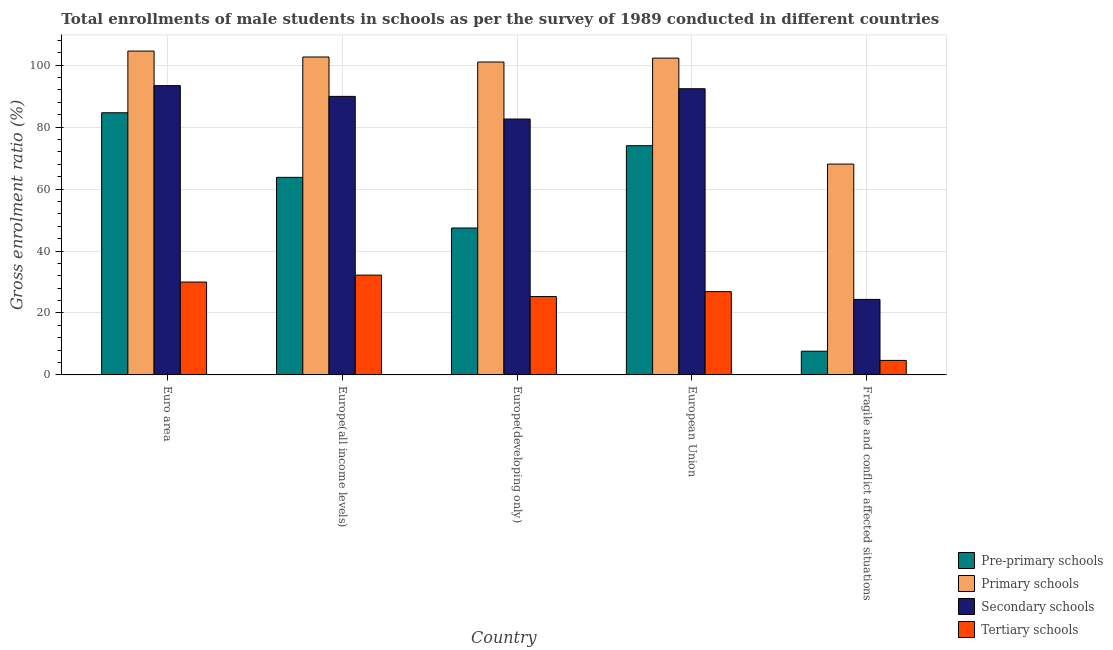How many bars are there on the 2nd tick from the left?
Offer a very short reply. 4. How many bars are there on the 4th tick from the right?
Your answer should be very brief. 4. What is the label of the 5th group of bars from the left?
Offer a very short reply. Fragile and conflict affected situations. In how many cases, is the number of bars for a given country not equal to the number of legend labels?
Keep it short and to the point. 0. What is the gross enrolment ratio(male) in secondary schools in Euro area?
Offer a terse response. 93.39. Across all countries, what is the maximum gross enrolment ratio(male) in pre-primary schools?
Keep it short and to the point. 84.63. Across all countries, what is the minimum gross enrolment ratio(male) in primary schools?
Offer a terse response. 68.07. In which country was the gross enrolment ratio(male) in tertiary schools maximum?
Provide a short and direct response. Europe(all income levels). In which country was the gross enrolment ratio(male) in primary schools minimum?
Offer a terse response. Fragile and conflict affected situations. What is the total gross enrolment ratio(male) in secondary schools in the graph?
Your answer should be very brief. 382.68. What is the difference between the gross enrolment ratio(male) in secondary schools in Europe(all income levels) and that in European Union?
Provide a succinct answer. -2.47. What is the difference between the gross enrolment ratio(male) in primary schools in Euro area and the gross enrolment ratio(male) in tertiary schools in Europe(all income levels)?
Provide a succinct answer. 72.33. What is the average gross enrolment ratio(male) in tertiary schools per country?
Ensure brevity in your answer.  23.81. What is the difference between the gross enrolment ratio(male) in primary schools and gross enrolment ratio(male) in secondary schools in Europe(all income levels)?
Keep it short and to the point. 12.72. What is the ratio of the gross enrolment ratio(male) in secondary schools in Euro area to that in European Union?
Provide a short and direct response. 1.01. What is the difference between the highest and the second highest gross enrolment ratio(male) in tertiary schools?
Ensure brevity in your answer.  2.24. What is the difference between the highest and the lowest gross enrolment ratio(male) in primary schools?
Provide a succinct answer. 36.48. In how many countries, is the gross enrolment ratio(male) in secondary schools greater than the average gross enrolment ratio(male) in secondary schools taken over all countries?
Keep it short and to the point. 4. Is the sum of the gross enrolment ratio(male) in primary schools in Euro area and Fragile and conflict affected situations greater than the maximum gross enrolment ratio(male) in pre-primary schools across all countries?
Provide a succinct answer. Yes. What does the 1st bar from the left in Fragile and conflict affected situations represents?
Ensure brevity in your answer.  Pre-primary schools. What does the 4th bar from the right in European Union represents?
Make the answer very short. Pre-primary schools. Is it the case that in every country, the sum of the gross enrolment ratio(male) in pre-primary schools and gross enrolment ratio(male) in primary schools is greater than the gross enrolment ratio(male) in secondary schools?
Provide a succinct answer. Yes. How many bars are there?
Make the answer very short. 20. How many countries are there in the graph?
Your response must be concise. 5. What is the difference between two consecutive major ticks on the Y-axis?
Offer a terse response. 20. Are the values on the major ticks of Y-axis written in scientific E-notation?
Provide a succinct answer. No. Does the graph contain grids?
Keep it short and to the point. Yes. Where does the legend appear in the graph?
Your answer should be compact. Bottom right. What is the title of the graph?
Make the answer very short. Total enrollments of male students in schools as per the survey of 1989 conducted in different countries. What is the label or title of the X-axis?
Keep it short and to the point. Country. What is the Gross enrolment ratio (%) of Pre-primary schools in Euro area?
Make the answer very short. 84.63. What is the Gross enrolment ratio (%) in Primary schools in Euro area?
Offer a very short reply. 104.55. What is the Gross enrolment ratio (%) in Secondary schools in Euro area?
Your answer should be compact. 93.39. What is the Gross enrolment ratio (%) of Tertiary schools in Euro area?
Offer a terse response. 29.98. What is the Gross enrolment ratio (%) in Pre-primary schools in Europe(all income levels)?
Your answer should be compact. 63.78. What is the Gross enrolment ratio (%) in Primary schools in Europe(all income levels)?
Your response must be concise. 102.63. What is the Gross enrolment ratio (%) of Secondary schools in Europe(all income levels)?
Provide a succinct answer. 89.92. What is the Gross enrolment ratio (%) in Tertiary schools in Europe(all income levels)?
Your response must be concise. 32.22. What is the Gross enrolment ratio (%) of Pre-primary schools in Europe(developing only)?
Provide a short and direct response. 47.42. What is the Gross enrolment ratio (%) in Primary schools in Europe(developing only)?
Your answer should be compact. 101.01. What is the Gross enrolment ratio (%) of Secondary schools in Europe(developing only)?
Make the answer very short. 82.61. What is the Gross enrolment ratio (%) of Tertiary schools in Europe(developing only)?
Make the answer very short. 25.29. What is the Gross enrolment ratio (%) of Pre-primary schools in European Union?
Your response must be concise. 73.99. What is the Gross enrolment ratio (%) in Primary schools in European Union?
Give a very brief answer. 102.27. What is the Gross enrolment ratio (%) in Secondary schools in European Union?
Ensure brevity in your answer.  92.39. What is the Gross enrolment ratio (%) in Tertiary schools in European Union?
Your response must be concise. 26.89. What is the Gross enrolment ratio (%) of Pre-primary schools in Fragile and conflict affected situations?
Your answer should be compact. 7.65. What is the Gross enrolment ratio (%) in Primary schools in Fragile and conflict affected situations?
Give a very brief answer. 68.07. What is the Gross enrolment ratio (%) in Secondary schools in Fragile and conflict affected situations?
Offer a terse response. 24.38. What is the Gross enrolment ratio (%) of Tertiary schools in Fragile and conflict affected situations?
Offer a terse response. 4.68. Across all countries, what is the maximum Gross enrolment ratio (%) of Pre-primary schools?
Your answer should be compact. 84.63. Across all countries, what is the maximum Gross enrolment ratio (%) of Primary schools?
Make the answer very short. 104.55. Across all countries, what is the maximum Gross enrolment ratio (%) of Secondary schools?
Your answer should be compact. 93.39. Across all countries, what is the maximum Gross enrolment ratio (%) of Tertiary schools?
Provide a succinct answer. 32.22. Across all countries, what is the minimum Gross enrolment ratio (%) of Pre-primary schools?
Provide a short and direct response. 7.65. Across all countries, what is the minimum Gross enrolment ratio (%) in Primary schools?
Your response must be concise. 68.07. Across all countries, what is the minimum Gross enrolment ratio (%) of Secondary schools?
Offer a very short reply. 24.38. Across all countries, what is the minimum Gross enrolment ratio (%) in Tertiary schools?
Offer a terse response. 4.68. What is the total Gross enrolment ratio (%) in Pre-primary schools in the graph?
Your response must be concise. 277.47. What is the total Gross enrolment ratio (%) in Primary schools in the graph?
Ensure brevity in your answer.  478.53. What is the total Gross enrolment ratio (%) of Secondary schools in the graph?
Offer a terse response. 382.68. What is the total Gross enrolment ratio (%) in Tertiary schools in the graph?
Offer a very short reply. 119.06. What is the difference between the Gross enrolment ratio (%) of Pre-primary schools in Euro area and that in Europe(all income levels)?
Provide a succinct answer. 20.85. What is the difference between the Gross enrolment ratio (%) in Primary schools in Euro area and that in Europe(all income levels)?
Your answer should be compact. 1.91. What is the difference between the Gross enrolment ratio (%) in Secondary schools in Euro area and that in Europe(all income levels)?
Ensure brevity in your answer.  3.47. What is the difference between the Gross enrolment ratio (%) of Tertiary schools in Euro area and that in Europe(all income levels)?
Your response must be concise. -2.24. What is the difference between the Gross enrolment ratio (%) in Pre-primary schools in Euro area and that in Europe(developing only)?
Offer a terse response. 37.21. What is the difference between the Gross enrolment ratio (%) of Primary schools in Euro area and that in Europe(developing only)?
Your response must be concise. 3.54. What is the difference between the Gross enrolment ratio (%) of Secondary schools in Euro area and that in Europe(developing only)?
Provide a succinct answer. 10.79. What is the difference between the Gross enrolment ratio (%) in Tertiary schools in Euro area and that in Europe(developing only)?
Provide a succinct answer. 4.69. What is the difference between the Gross enrolment ratio (%) of Pre-primary schools in Euro area and that in European Union?
Provide a short and direct response. 10.64. What is the difference between the Gross enrolment ratio (%) in Primary schools in Euro area and that in European Union?
Provide a short and direct response. 2.28. What is the difference between the Gross enrolment ratio (%) in Tertiary schools in Euro area and that in European Union?
Provide a succinct answer. 3.09. What is the difference between the Gross enrolment ratio (%) in Pre-primary schools in Euro area and that in Fragile and conflict affected situations?
Your answer should be compact. 76.98. What is the difference between the Gross enrolment ratio (%) of Primary schools in Euro area and that in Fragile and conflict affected situations?
Your answer should be very brief. 36.48. What is the difference between the Gross enrolment ratio (%) in Secondary schools in Euro area and that in Fragile and conflict affected situations?
Your answer should be very brief. 69.01. What is the difference between the Gross enrolment ratio (%) in Tertiary schools in Euro area and that in Fragile and conflict affected situations?
Ensure brevity in your answer.  25.3. What is the difference between the Gross enrolment ratio (%) of Pre-primary schools in Europe(all income levels) and that in Europe(developing only)?
Make the answer very short. 16.35. What is the difference between the Gross enrolment ratio (%) in Primary schools in Europe(all income levels) and that in Europe(developing only)?
Make the answer very short. 1.62. What is the difference between the Gross enrolment ratio (%) of Secondary schools in Europe(all income levels) and that in Europe(developing only)?
Give a very brief answer. 7.31. What is the difference between the Gross enrolment ratio (%) of Tertiary schools in Europe(all income levels) and that in Europe(developing only)?
Make the answer very short. 6.93. What is the difference between the Gross enrolment ratio (%) in Pre-primary schools in Europe(all income levels) and that in European Union?
Give a very brief answer. -10.21. What is the difference between the Gross enrolment ratio (%) of Primary schools in Europe(all income levels) and that in European Union?
Provide a short and direct response. 0.36. What is the difference between the Gross enrolment ratio (%) of Secondary schools in Europe(all income levels) and that in European Union?
Ensure brevity in your answer.  -2.47. What is the difference between the Gross enrolment ratio (%) of Tertiary schools in Europe(all income levels) and that in European Union?
Your answer should be compact. 5.33. What is the difference between the Gross enrolment ratio (%) of Pre-primary schools in Europe(all income levels) and that in Fragile and conflict affected situations?
Make the answer very short. 56.13. What is the difference between the Gross enrolment ratio (%) in Primary schools in Europe(all income levels) and that in Fragile and conflict affected situations?
Make the answer very short. 34.57. What is the difference between the Gross enrolment ratio (%) of Secondary schools in Europe(all income levels) and that in Fragile and conflict affected situations?
Offer a terse response. 65.54. What is the difference between the Gross enrolment ratio (%) in Tertiary schools in Europe(all income levels) and that in Fragile and conflict affected situations?
Offer a terse response. 27.54. What is the difference between the Gross enrolment ratio (%) in Pre-primary schools in Europe(developing only) and that in European Union?
Your answer should be very brief. -26.57. What is the difference between the Gross enrolment ratio (%) in Primary schools in Europe(developing only) and that in European Union?
Ensure brevity in your answer.  -1.26. What is the difference between the Gross enrolment ratio (%) in Secondary schools in Europe(developing only) and that in European Union?
Make the answer very short. -9.78. What is the difference between the Gross enrolment ratio (%) of Tertiary schools in Europe(developing only) and that in European Union?
Your response must be concise. -1.6. What is the difference between the Gross enrolment ratio (%) in Pre-primary schools in Europe(developing only) and that in Fragile and conflict affected situations?
Offer a very short reply. 39.77. What is the difference between the Gross enrolment ratio (%) of Primary schools in Europe(developing only) and that in Fragile and conflict affected situations?
Keep it short and to the point. 32.94. What is the difference between the Gross enrolment ratio (%) of Secondary schools in Europe(developing only) and that in Fragile and conflict affected situations?
Make the answer very short. 58.23. What is the difference between the Gross enrolment ratio (%) of Tertiary schools in Europe(developing only) and that in Fragile and conflict affected situations?
Your answer should be very brief. 20.61. What is the difference between the Gross enrolment ratio (%) of Pre-primary schools in European Union and that in Fragile and conflict affected situations?
Provide a succinct answer. 66.34. What is the difference between the Gross enrolment ratio (%) in Primary schools in European Union and that in Fragile and conflict affected situations?
Your answer should be compact. 34.2. What is the difference between the Gross enrolment ratio (%) of Secondary schools in European Union and that in Fragile and conflict affected situations?
Your answer should be very brief. 68.01. What is the difference between the Gross enrolment ratio (%) in Tertiary schools in European Union and that in Fragile and conflict affected situations?
Ensure brevity in your answer.  22.21. What is the difference between the Gross enrolment ratio (%) of Pre-primary schools in Euro area and the Gross enrolment ratio (%) of Primary schools in Europe(all income levels)?
Offer a terse response. -18. What is the difference between the Gross enrolment ratio (%) in Pre-primary schools in Euro area and the Gross enrolment ratio (%) in Secondary schools in Europe(all income levels)?
Your response must be concise. -5.29. What is the difference between the Gross enrolment ratio (%) in Pre-primary schools in Euro area and the Gross enrolment ratio (%) in Tertiary schools in Europe(all income levels)?
Your answer should be compact. 52.41. What is the difference between the Gross enrolment ratio (%) of Primary schools in Euro area and the Gross enrolment ratio (%) of Secondary schools in Europe(all income levels)?
Give a very brief answer. 14.63. What is the difference between the Gross enrolment ratio (%) of Primary schools in Euro area and the Gross enrolment ratio (%) of Tertiary schools in Europe(all income levels)?
Your answer should be compact. 72.33. What is the difference between the Gross enrolment ratio (%) of Secondary schools in Euro area and the Gross enrolment ratio (%) of Tertiary schools in Europe(all income levels)?
Keep it short and to the point. 61.17. What is the difference between the Gross enrolment ratio (%) of Pre-primary schools in Euro area and the Gross enrolment ratio (%) of Primary schools in Europe(developing only)?
Provide a short and direct response. -16.38. What is the difference between the Gross enrolment ratio (%) of Pre-primary schools in Euro area and the Gross enrolment ratio (%) of Secondary schools in Europe(developing only)?
Give a very brief answer. 2.03. What is the difference between the Gross enrolment ratio (%) in Pre-primary schools in Euro area and the Gross enrolment ratio (%) in Tertiary schools in Europe(developing only)?
Offer a terse response. 59.34. What is the difference between the Gross enrolment ratio (%) in Primary schools in Euro area and the Gross enrolment ratio (%) in Secondary schools in Europe(developing only)?
Your answer should be very brief. 21.94. What is the difference between the Gross enrolment ratio (%) of Primary schools in Euro area and the Gross enrolment ratio (%) of Tertiary schools in Europe(developing only)?
Ensure brevity in your answer.  79.26. What is the difference between the Gross enrolment ratio (%) of Secondary schools in Euro area and the Gross enrolment ratio (%) of Tertiary schools in Europe(developing only)?
Make the answer very short. 68.1. What is the difference between the Gross enrolment ratio (%) in Pre-primary schools in Euro area and the Gross enrolment ratio (%) in Primary schools in European Union?
Provide a short and direct response. -17.64. What is the difference between the Gross enrolment ratio (%) of Pre-primary schools in Euro area and the Gross enrolment ratio (%) of Secondary schools in European Union?
Your response must be concise. -7.76. What is the difference between the Gross enrolment ratio (%) of Pre-primary schools in Euro area and the Gross enrolment ratio (%) of Tertiary schools in European Union?
Provide a short and direct response. 57.74. What is the difference between the Gross enrolment ratio (%) of Primary schools in Euro area and the Gross enrolment ratio (%) of Secondary schools in European Union?
Your answer should be very brief. 12.16. What is the difference between the Gross enrolment ratio (%) of Primary schools in Euro area and the Gross enrolment ratio (%) of Tertiary schools in European Union?
Your answer should be very brief. 77.66. What is the difference between the Gross enrolment ratio (%) in Secondary schools in Euro area and the Gross enrolment ratio (%) in Tertiary schools in European Union?
Keep it short and to the point. 66.5. What is the difference between the Gross enrolment ratio (%) in Pre-primary schools in Euro area and the Gross enrolment ratio (%) in Primary schools in Fragile and conflict affected situations?
Offer a terse response. 16.56. What is the difference between the Gross enrolment ratio (%) in Pre-primary schools in Euro area and the Gross enrolment ratio (%) in Secondary schools in Fragile and conflict affected situations?
Offer a very short reply. 60.25. What is the difference between the Gross enrolment ratio (%) in Pre-primary schools in Euro area and the Gross enrolment ratio (%) in Tertiary schools in Fragile and conflict affected situations?
Make the answer very short. 79.95. What is the difference between the Gross enrolment ratio (%) of Primary schools in Euro area and the Gross enrolment ratio (%) of Secondary schools in Fragile and conflict affected situations?
Ensure brevity in your answer.  80.17. What is the difference between the Gross enrolment ratio (%) of Primary schools in Euro area and the Gross enrolment ratio (%) of Tertiary schools in Fragile and conflict affected situations?
Your response must be concise. 99.87. What is the difference between the Gross enrolment ratio (%) in Secondary schools in Euro area and the Gross enrolment ratio (%) in Tertiary schools in Fragile and conflict affected situations?
Provide a succinct answer. 88.71. What is the difference between the Gross enrolment ratio (%) in Pre-primary schools in Europe(all income levels) and the Gross enrolment ratio (%) in Primary schools in Europe(developing only)?
Your answer should be compact. -37.23. What is the difference between the Gross enrolment ratio (%) of Pre-primary schools in Europe(all income levels) and the Gross enrolment ratio (%) of Secondary schools in Europe(developing only)?
Give a very brief answer. -18.83. What is the difference between the Gross enrolment ratio (%) in Pre-primary schools in Europe(all income levels) and the Gross enrolment ratio (%) in Tertiary schools in Europe(developing only)?
Your answer should be compact. 38.49. What is the difference between the Gross enrolment ratio (%) of Primary schools in Europe(all income levels) and the Gross enrolment ratio (%) of Secondary schools in Europe(developing only)?
Provide a succinct answer. 20.03. What is the difference between the Gross enrolment ratio (%) of Primary schools in Europe(all income levels) and the Gross enrolment ratio (%) of Tertiary schools in Europe(developing only)?
Keep it short and to the point. 77.34. What is the difference between the Gross enrolment ratio (%) of Secondary schools in Europe(all income levels) and the Gross enrolment ratio (%) of Tertiary schools in Europe(developing only)?
Your answer should be compact. 64.63. What is the difference between the Gross enrolment ratio (%) in Pre-primary schools in Europe(all income levels) and the Gross enrolment ratio (%) in Primary schools in European Union?
Give a very brief answer. -38.49. What is the difference between the Gross enrolment ratio (%) in Pre-primary schools in Europe(all income levels) and the Gross enrolment ratio (%) in Secondary schools in European Union?
Provide a short and direct response. -28.61. What is the difference between the Gross enrolment ratio (%) of Pre-primary schools in Europe(all income levels) and the Gross enrolment ratio (%) of Tertiary schools in European Union?
Offer a terse response. 36.89. What is the difference between the Gross enrolment ratio (%) in Primary schools in Europe(all income levels) and the Gross enrolment ratio (%) in Secondary schools in European Union?
Provide a short and direct response. 10.24. What is the difference between the Gross enrolment ratio (%) in Primary schools in Europe(all income levels) and the Gross enrolment ratio (%) in Tertiary schools in European Union?
Your answer should be very brief. 75.74. What is the difference between the Gross enrolment ratio (%) of Secondary schools in Europe(all income levels) and the Gross enrolment ratio (%) of Tertiary schools in European Union?
Provide a short and direct response. 63.03. What is the difference between the Gross enrolment ratio (%) in Pre-primary schools in Europe(all income levels) and the Gross enrolment ratio (%) in Primary schools in Fragile and conflict affected situations?
Your answer should be very brief. -4.29. What is the difference between the Gross enrolment ratio (%) in Pre-primary schools in Europe(all income levels) and the Gross enrolment ratio (%) in Secondary schools in Fragile and conflict affected situations?
Provide a succinct answer. 39.4. What is the difference between the Gross enrolment ratio (%) in Pre-primary schools in Europe(all income levels) and the Gross enrolment ratio (%) in Tertiary schools in Fragile and conflict affected situations?
Your answer should be very brief. 59.09. What is the difference between the Gross enrolment ratio (%) in Primary schools in Europe(all income levels) and the Gross enrolment ratio (%) in Secondary schools in Fragile and conflict affected situations?
Offer a terse response. 78.26. What is the difference between the Gross enrolment ratio (%) in Primary schools in Europe(all income levels) and the Gross enrolment ratio (%) in Tertiary schools in Fragile and conflict affected situations?
Provide a succinct answer. 97.95. What is the difference between the Gross enrolment ratio (%) in Secondary schools in Europe(all income levels) and the Gross enrolment ratio (%) in Tertiary schools in Fragile and conflict affected situations?
Your answer should be very brief. 85.23. What is the difference between the Gross enrolment ratio (%) in Pre-primary schools in Europe(developing only) and the Gross enrolment ratio (%) in Primary schools in European Union?
Provide a short and direct response. -54.85. What is the difference between the Gross enrolment ratio (%) of Pre-primary schools in Europe(developing only) and the Gross enrolment ratio (%) of Secondary schools in European Union?
Provide a short and direct response. -44.97. What is the difference between the Gross enrolment ratio (%) of Pre-primary schools in Europe(developing only) and the Gross enrolment ratio (%) of Tertiary schools in European Union?
Your answer should be very brief. 20.53. What is the difference between the Gross enrolment ratio (%) in Primary schools in Europe(developing only) and the Gross enrolment ratio (%) in Secondary schools in European Union?
Your answer should be compact. 8.62. What is the difference between the Gross enrolment ratio (%) in Primary schools in Europe(developing only) and the Gross enrolment ratio (%) in Tertiary schools in European Union?
Provide a short and direct response. 74.12. What is the difference between the Gross enrolment ratio (%) in Secondary schools in Europe(developing only) and the Gross enrolment ratio (%) in Tertiary schools in European Union?
Offer a very short reply. 55.72. What is the difference between the Gross enrolment ratio (%) in Pre-primary schools in Europe(developing only) and the Gross enrolment ratio (%) in Primary schools in Fragile and conflict affected situations?
Give a very brief answer. -20.64. What is the difference between the Gross enrolment ratio (%) of Pre-primary schools in Europe(developing only) and the Gross enrolment ratio (%) of Secondary schools in Fragile and conflict affected situations?
Your response must be concise. 23.05. What is the difference between the Gross enrolment ratio (%) in Pre-primary schools in Europe(developing only) and the Gross enrolment ratio (%) in Tertiary schools in Fragile and conflict affected situations?
Provide a succinct answer. 42.74. What is the difference between the Gross enrolment ratio (%) of Primary schools in Europe(developing only) and the Gross enrolment ratio (%) of Secondary schools in Fragile and conflict affected situations?
Give a very brief answer. 76.63. What is the difference between the Gross enrolment ratio (%) in Primary schools in Europe(developing only) and the Gross enrolment ratio (%) in Tertiary schools in Fragile and conflict affected situations?
Your answer should be very brief. 96.33. What is the difference between the Gross enrolment ratio (%) of Secondary schools in Europe(developing only) and the Gross enrolment ratio (%) of Tertiary schools in Fragile and conflict affected situations?
Ensure brevity in your answer.  77.92. What is the difference between the Gross enrolment ratio (%) of Pre-primary schools in European Union and the Gross enrolment ratio (%) of Primary schools in Fragile and conflict affected situations?
Your response must be concise. 5.93. What is the difference between the Gross enrolment ratio (%) of Pre-primary schools in European Union and the Gross enrolment ratio (%) of Secondary schools in Fragile and conflict affected situations?
Keep it short and to the point. 49.61. What is the difference between the Gross enrolment ratio (%) of Pre-primary schools in European Union and the Gross enrolment ratio (%) of Tertiary schools in Fragile and conflict affected situations?
Make the answer very short. 69.31. What is the difference between the Gross enrolment ratio (%) in Primary schools in European Union and the Gross enrolment ratio (%) in Secondary schools in Fragile and conflict affected situations?
Offer a terse response. 77.89. What is the difference between the Gross enrolment ratio (%) of Primary schools in European Union and the Gross enrolment ratio (%) of Tertiary schools in Fragile and conflict affected situations?
Ensure brevity in your answer.  97.59. What is the difference between the Gross enrolment ratio (%) of Secondary schools in European Union and the Gross enrolment ratio (%) of Tertiary schools in Fragile and conflict affected situations?
Give a very brief answer. 87.71. What is the average Gross enrolment ratio (%) in Pre-primary schools per country?
Offer a very short reply. 55.49. What is the average Gross enrolment ratio (%) of Primary schools per country?
Give a very brief answer. 95.71. What is the average Gross enrolment ratio (%) of Secondary schools per country?
Keep it short and to the point. 76.54. What is the average Gross enrolment ratio (%) in Tertiary schools per country?
Provide a short and direct response. 23.81. What is the difference between the Gross enrolment ratio (%) in Pre-primary schools and Gross enrolment ratio (%) in Primary schools in Euro area?
Ensure brevity in your answer.  -19.92. What is the difference between the Gross enrolment ratio (%) in Pre-primary schools and Gross enrolment ratio (%) in Secondary schools in Euro area?
Offer a terse response. -8.76. What is the difference between the Gross enrolment ratio (%) in Pre-primary schools and Gross enrolment ratio (%) in Tertiary schools in Euro area?
Offer a very short reply. 54.65. What is the difference between the Gross enrolment ratio (%) of Primary schools and Gross enrolment ratio (%) of Secondary schools in Euro area?
Provide a short and direct response. 11.16. What is the difference between the Gross enrolment ratio (%) of Primary schools and Gross enrolment ratio (%) of Tertiary schools in Euro area?
Provide a short and direct response. 74.57. What is the difference between the Gross enrolment ratio (%) in Secondary schools and Gross enrolment ratio (%) in Tertiary schools in Euro area?
Your response must be concise. 63.41. What is the difference between the Gross enrolment ratio (%) of Pre-primary schools and Gross enrolment ratio (%) of Primary schools in Europe(all income levels)?
Your response must be concise. -38.86. What is the difference between the Gross enrolment ratio (%) in Pre-primary schools and Gross enrolment ratio (%) in Secondary schools in Europe(all income levels)?
Your answer should be compact. -26.14. What is the difference between the Gross enrolment ratio (%) of Pre-primary schools and Gross enrolment ratio (%) of Tertiary schools in Europe(all income levels)?
Your answer should be compact. 31.56. What is the difference between the Gross enrolment ratio (%) in Primary schools and Gross enrolment ratio (%) in Secondary schools in Europe(all income levels)?
Ensure brevity in your answer.  12.72. What is the difference between the Gross enrolment ratio (%) in Primary schools and Gross enrolment ratio (%) in Tertiary schools in Europe(all income levels)?
Provide a succinct answer. 70.42. What is the difference between the Gross enrolment ratio (%) in Secondary schools and Gross enrolment ratio (%) in Tertiary schools in Europe(all income levels)?
Offer a very short reply. 57.7. What is the difference between the Gross enrolment ratio (%) in Pre-primary schools and Gross enrolment ratio (%) in Primary schools in Europe(developing only)?
Your answer should be very brief. -53.59. What is the difference between the Gross enrolment ratio (%) in Pre-primary schools and Gross enrolment ratio (%) in Secondary schools in Europe(developing only)?
Your response must be concise. -35.18. What is the difference between the Gross enrolment ratio (%) of Pre-primary schools and Gross enrolment ratio (%) of Tertiary schools in Europe(developing only)?
Give a very brief answer. 22.13. What is the difference between the Gross enrolment ratio (%) of Primary schools and Gross enrolment ratio (%) of Secondary schools in Europe(developing only)?
Your response must be concise. 18.4. What is the difference between the Gross enrolment ratio (%) in Primary schools and Gross enrolment ratio (%) in Tertiary schools in Europe(developing only)?
Provide a short and direct response. 75.72. What is the difference between the Gross enrolment ratio (%) of Secondary schools and Gross enrolment ratio (%) of Tertiary schools in Europe(developing only)?
Your response must be concise. 57.31. What is the difference between the Gross enrolment ratio (%) of Pre-primary schools and Gross enrolment ratio (%) of Primary schools in European Union?
Your answer should be very brief. -28.28. What is the difference between the Gross enrolment ratio (%) in Pre-primary schools and Gross enrolment ratio (%) in Secondary schools in European Union?
Provide a succinct answer. -18.4. What is the difference between the Gross enrolment ratio (%) of Pre-primary schools and Gross enrolment ratio (%) of Tertiary schools in European Union?
Provide a succinct answer. 47.1. What is the difference between the Gross enrolment ratio (%) in Primary schools and Gross enrolment ratio (%) in Secondary schools in European Union?
Ensure brevity in your answer.  9.88. What is the difference between the Gross enrolment ratio (%) of Primary schools and Gross enrolment ratio (%) of Tertiary schools in European Union?
Your answer should be compact. 75.38. What is the difference between the Gross enrolment ratio (%) in Secondary schools and Gross enrolment ratio (%) in Tertiary schools in European Union?
Your response must be concise. 65.5. What is the difference between the Gross enrolment ratio (%) in Pre-primary schools and Gross enrolment ratio (%) in Primary schools in Fragile and conflict affected situations?
Keep it short and to the point. -60.41. What is the difference between the Gross enrolment ratio (%) of Pre-primary schools and Gross enrolment ratio (%) of Secondary schools in Fragile and conflict affected situations?
Your response must be concise. -16.73. What is the difference between the Gross enrolment ratio (%) of Pre-primary schools and Gross enrolment ratio (%) of Tertiary schools in Fragile and conflict affected situations?
Your answer should be compact. 2.97. What is the difference between the Gross enrolment ratio (%) of Primary schools and Gross enrolment ratio (%) of Secondary schools in Fragile and conflict affected situations?
Your answer should be compact. 43.69. What is the difference between the Gross enrolment ratio (%) in Primary schools and Gross enrolment ratio (%) in Tertiary schools in Fragile and conflict affected situations?
Keep it short and to the point. 63.38. What is the difference between the Gross enrolment ratio (%) in Secondary schools and Gross enrolment ratio (%) in Tertiary schools in Fragile and conflict affected situations?
Offer a very short reply. 19.7. What is the ratio of the Gross enrolment ratio (%) in Pre-primary schools in Euro area to that in Europe(all income levels)?
Provide a short and direct response. 1.33. What is the ratio of the Gross enrolment ratio (%) in Primary schools in Euro area to that in Europe(all income levels)?
Make the answer very short. 1.02. What is the ratio of the Gross enrolment ratio (%) in Secondary schools in Euro area to that in Europe(all income levels)?
Give a very brief answer. 1.04. What is the ratio of the Gross enrolment ratio (%) of Tertiary schools in Euro area to that in Europe(all income levels)?
Ensure brevity in your answer.  0.93. What is the ratio of the Gross enrolment ratio (%) of Pre-primary schools in Euro area to that in Europe(developing only)?
Your response must be concise. 1.78. What is the ratio of the Gross enrolment ratio (%) of Primary schools in Euro area to that in Europe(developing only)?
Provide a succinct answer. 1.03. What is the ratio of the Gross enrolment ratio (%) of Secondary schools in Euro area to that in Europe(developing only)?
Provide a succinct answer. 1.13. What is the ratio of the Gross enrolment ratio (%) of Tertiary schools in Euro area to that in Europe(developing only)?
Your response must be concise. 1.19. What is the ratio of the Gross enrolment ratio (%) of Pre-primary schools in Euro area to that in European Union?
Your response must be concise. 1.14. What is the ratio of the Gross enrolment ratio (%) in Primary schools in Euro area to that in European Union?
Provide a succinct answer. 1.02. What is the ratio of the Gross enrolment ratio (%) of Secondary schools in Euro area to that in European Union?
Your answer should be very brief. 1.01. What is the ratio of the Gross enrolment ratio (%) in Tertiary schools in Euro area to that in European Union?
Keep it short and to the point. 1.11. What is the ratio of the Gross enrolment ratio (%) in Pre-primary schools in Euro area to that in Fragile and conflict affected situations?
Give a very brief answer. 11.06. What is the ratio of the Gross enrolment ratio (%) of Primary schools in Euro area to that in Fragile and conflict affected situations?
Keep it short and to the point. 1.54. What is the ratio of the Gross enrolment ratio (%) in Secondary schools in Euro area to that in Fragile and conflict affected situations?
Your answer should be very brief. 3.83. What is the ratio of the Gross enrolment ratio (%) in Tertiary schools in Euro area to that in Fragile and conflict affected situations?
Your answer should be very brief. 6.4. What is the ratio of the Gross enrolment ratio (%) in Pre-primary schools in Europe(all income levels) to that in Europe(developing only)?
Provide a succinct answer. 1.34. What is the ratio of the Gross enrolment ratio (%) of Primary schools in Europe(all income levels) to that in Europe(developing only)?
Ensure brevity in your answer.  1.02. What is the ratio of the Gross enrolment ratio (%) of Secondary schools in Europe(all income levels) to that in Europe(developing only)?
Offer a terse response. 1.09. What is the ratio of the Gross enrolment ratio (%) in Tertiary schools in Europe(all income levels) to that in Europe(developing only)?
Offer a terse response. 1.27. What is the ratio of the Gross enrolment ratio (%) in Pre-primary schools in Europe(all income levels) to that in European Union?
Your response must be concise. 0.86. What is the ratio of the Gross enrolment ratio (%) in Secondary schools in Europe(all income levels) to that in European Union?
Give a very brief answer. 0.97. What is the ratio of the Gross enrolment ratio (%) of Tertiary schools in Europe(all income levels) to that in European Union?
Your response must be concise. 1.2. What is the ratio of the Gross enrolment ratio (%) in Pre-primary schools in Europe(all income levels) to that in Fragile and conflict affected situations?
Your answer should be very brief. 8.34. What is the ratio of the Gross enrolment ratio (%) of Primary schools in Europe(all income levels) to that in Fragile and conflict affected situations?
Your response must be concise. 1.51. What is the ratio of the Gross enrolment ratio (%) in Secondary schools in Europe(all income levels) to that in Fragile and conflict affected situations?
Keep it short and to the point. 3.69. What is the ratio of the Gross enrolment ratio (%) of Tertiary schools in Europe(all income levels) to that in Fragile and conflict affected situations?
Your answer should be very brief. 6.88. What is the ratio of the Gross enrolment ratio (%) of Pre-primary schools in Europe(developing only) to that in European Union?
Ensure brevity in your answer.  0.64. What is the ratio of the Gross enrolment ratio (%) in Secondary schools in Europe(developing only) to that in European Union?
Your answer should be very brief. 0.89. What is the ratio of the Gross enrolment ratio (%) in Tertiary schools in Europe(developing only) to that in European Union?
Your answer should be very brief. 0.94. What is the ratio of the Gross enrolment ratio (%) of Pre-primary schools in Europe(developing only) to that in Fragile and conflict affected situations?
Ensure brevity in your answer.  6.2. What is the ratio of the Gross enrolment ratio (%) in Primary schools in Europe(developing only) to that in Fragile and conflict affected situations?
Give a very brief answer. 1.48. What is the ratio of the Gross enrolment ratio (%) in Secondary schools in Europe(developing only) to that in Fragile and conflict affected situations?
Provide a short and direct response. 3.39. What is the ratio of the Gross enrolment ratio (%) of Tertiary schools in Europe(developing only) to that in Fragile and conflict affected situations?
Provide a short and direct response. 5.4. What is the ratio of the Gross enrolment ratio (%) of Pre-primary schools in European Union to that in Fragile and conflict affected situations?
Provide a short and direct response. 9.67. What is the ratio of the Gross enrolment ratio (%) of Primary schools in European Union to that in Fragile and conflict affected situations?
Provide a short and direct response. 1.5. What is the ratio of the Gross enrolment ratio (%) in Secondary schools in European Union to that in Fragile and conflict affected situations?
Ensure brevity in your answer.  3.79. What is the ratio of the Gross enrolment ratio (%) in Tertiary schools in European Union to that in Fragile and conflict affected situations?
Ensure brevity in your answer.  5.74. What is the difference between the highest and the second highest Gross enrolment ratio (%) of Pre-primary schools?
Make the answer very short. 10.64. What is the difference between the highest and the second highest Gross enrolment ratio (%) of Primary schools?
Make the answer very short. 1.91. What is the difference between the highest and the second highest Gross enrolment ratio (%) of Secondary schools?
Give a very brief answer. 1. What is the difference between the highest and the second highest Gross enrolment ratio (%) in Tertiary schools?
Provide a succinct answer. 2.24. What is the difference between the highest and the lowest Gross enrolment ratio (%) of Pre-primary schools?
Your answer should be very brief. 76.98. What is the difference between the highest and the lowest Gross enrolment ratio (%) of Primary schools?
Ensure brevity in your answer.  36.48. What is the difference between the highest and the lowest Gross enrolment ratio (%) in Secondary schools?
Your answer should be very brief. 69.01. What is the difference between the highest and the lowest Gross enrolment ratio (%) in Tertiary schools?
Ensure brevity in your answer.  27.54. 